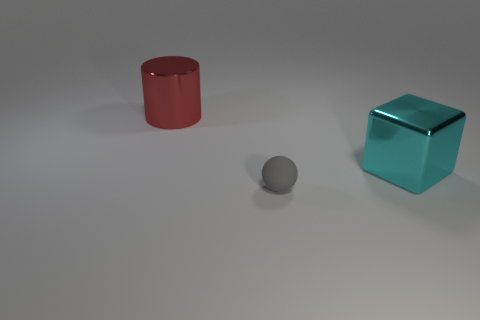Considering the positions of the objects, what can you infer about their arrangement? The objects are placed with space between them, suggesting a deliberate arrangement meant to showcase their shapes and colors distinctly. This spacing might indicate an illustrative purpose, such as a demonstration of geometry or a comparison of reflective properties. 